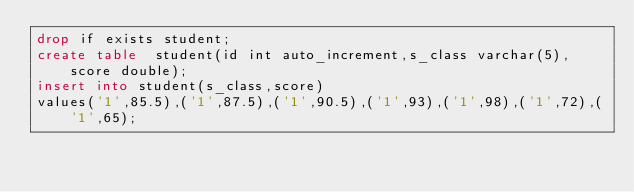<code> <loc_0><loc_0><loc_500><loc_500><_SQL_>drop if exists student;
create table  student(id int auto_increment,s_class varchar(5),score double);
insert into student(s_class,score)
values('1',85.5),('1',87.5),('1',90.5),('1',93),('1',98),('1',72),('1',65);</code> 